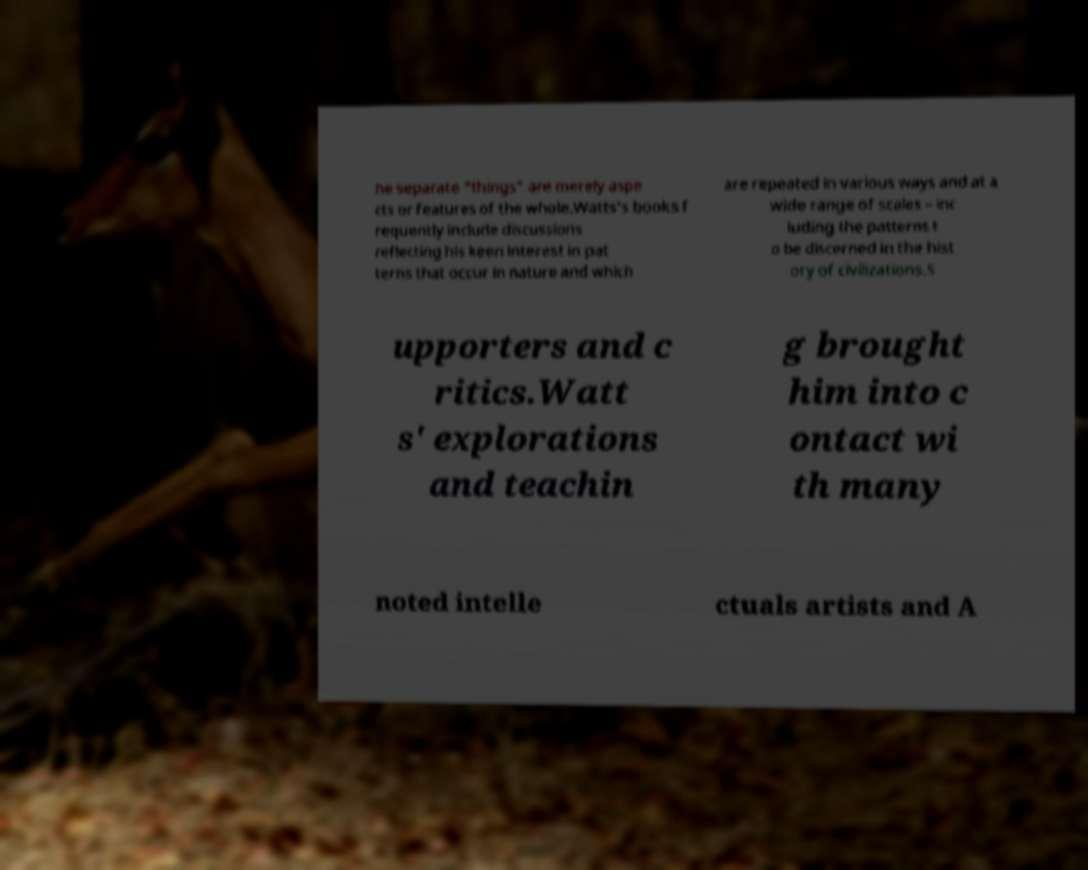For documentation purposes, I need the text within this image transcribed. Could you provide that? he separate "things" are merely aspe cts or features of the whole.Watts's books f requently include discussions reflecting his keen interest in pat terns that occur in nature and which are repeated in various ways and at a wide range of scales – inc luding the patterns t o be discerned in the hist ory of civilizations.S upporters and c ritics.Watt s' explorations and teachin g brought him into c ontact wi th many noted intelle ctuals artists and A 